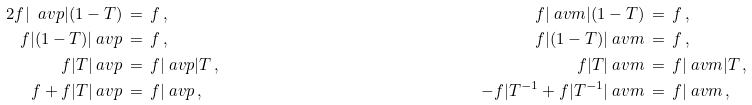Convert formula to latex. <formula><loc_0><loc_0><loc_500><loc_500>2 f | \ a v p | ( 1 - T ) & \, = \, f \, , & \quad f | \ a v m | ( 1 - T ) & \, = \, f \, , \\ f | ( 1 - T ) | \ a v p & \, = \, f \, , & \quad f | ( 1 - T ) | \ a v m & \, = \, f \, , \\ f | T | \ a v p & \, = \, f | \ a v p | T \, , & \quad f | T | \ a v m & \, = \, f | \ a v m | T \, , \\ f + f | T | \ a v p & \, = \, f | \ a v p \, , & \quad - f | T ^ { - 1 } + f | T ^ { - 1 } | \ a v m & \, = \, f | \ a v m \, ,</formula> 